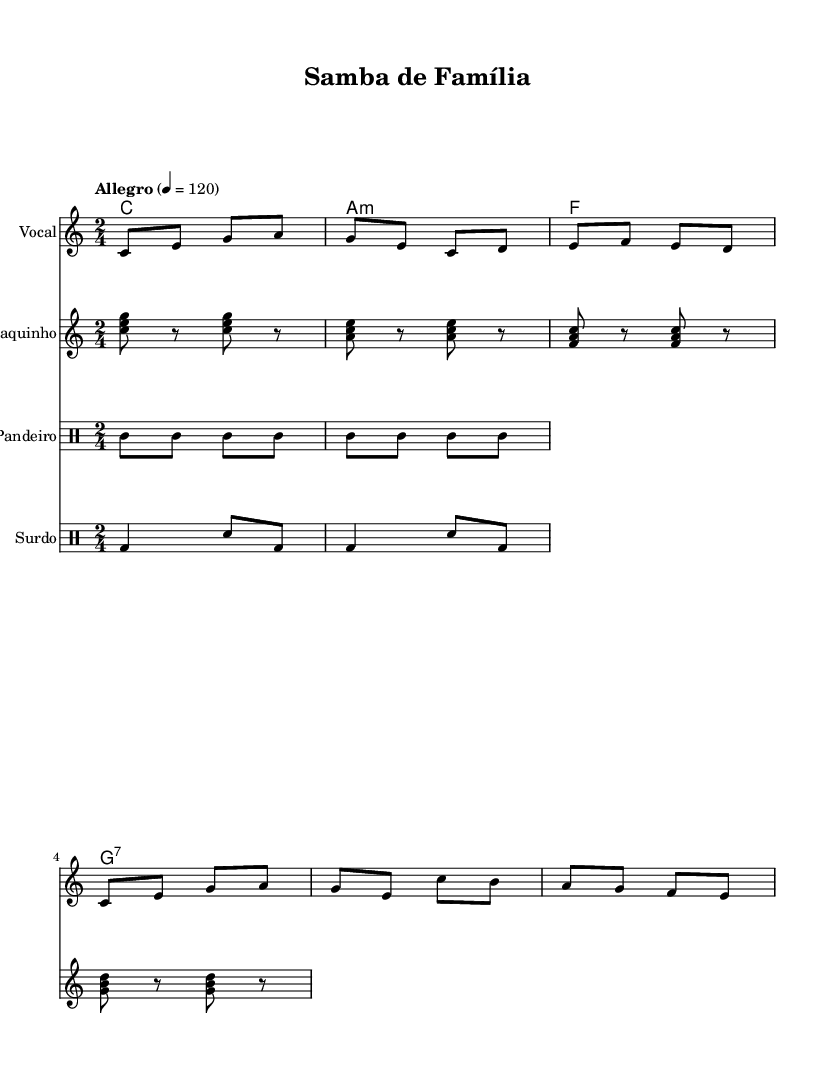What is the key signature of this music? The key signature is indicated at the beginning of the score, and it shows no sharps or flats, confirming the key of C major.
Answer: C major What is the time signature of this music? The time signature is shown at the beginning of the score, represented as 2/4, indicating two beats per measure with a quarter note getting one beat.
Answer: 2/4 What is the tempo marking for this piece? The tempo marking is noted as "Allegro," followed by a metronome indication of 4 = 120, which suggests a lively pace at a speed of 120 beats per minute.
Answer: Allegro How many measures are in the melody? By counting the individual segments divided by vertical lines (bar lines) in the melody part, we see there are a total of 8 measures.
Answer: 8 What is the primary instrument playing in the score? The primary instrument designated in the score is labeled as "Vocal," indicating that the main line is intended for voice.
Answer: Vocal What type of rhythmic percussion instruments are present in this piece? The score includes two distinct types of drum instruments labeled as "Pandeiro" and "Surdo," which are traditional percussion instruments used in samba music.
Answer: Pandeiro, Surdo What familial theme is represented in the lyrics? The lyrics convey a theme of family unity, with phrases that emphasize togetherness and shared experiences such as "Ir mã que" (referring to siblings or mother) and "Nos sa união" (our union).
Answer: Family unity 